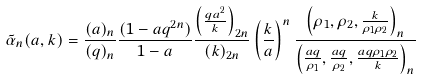<formula> <loc_0><loc_0><loc_500><loc_500>\tilde { \alpha } _ { n } ( a , k ) = \frac { ( a ) _ { n } } { ( q ) _ { n } } \frac { ( 1 - a q ^ { 2 n } ) } { 1 - a } \frac { \left ( \frac { q a ^ { 2 } } { k } \right ) _ { 2 n } } { ( k ) _ { 2 n } } \left ( \frac { k } { a } \right ) ^ { n } \frac { \left ( \rho _ { 1 } , \rho _ { 2 } , \frac { k } { \rho _ { 1 } \rho _ { 2 } } \right ) _ { n } } { \left ( \frac { a q } { \rho _ { 1 } } , \frac { a q } { \rho _ { 2 } } , \frac { a q \rho _ { 1 } \rho _ { 2 } } { k } \right ) _ { n } }</formula> 